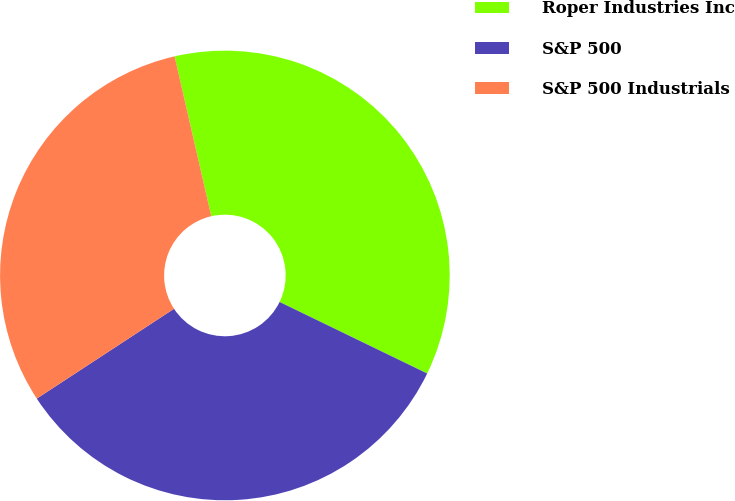Convert chart to OTSL. <chart><loc_0><loc_0><loc_500><loc_500><pie_chart><fcel>Roper Industries Inc<fcel>S&P 500<fcel>S&P 500 Industrials<nl><fcel>35.77%<fcel>33.59%<fcel>30.63%<nl></chart> 